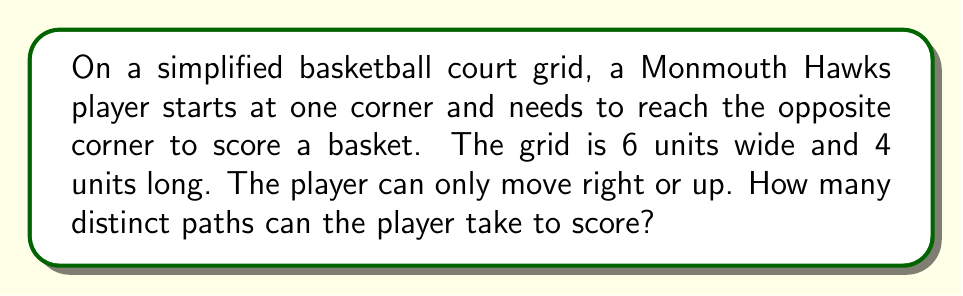Can you answer this question? Let's approach this step-by-step:

1) This is a classic combinatorics problem that can be solved using the concept of lattice paths.

2) The player needs to move 6 units right and 4 units up in total, regardless of the order.

3) Each distinct path will consist of exactly 10 moves (6 right + 4 up).

4) The question is essentially asking: in how many ways can we arrange 6 right moves and 4 up moves?

5) This is equivalent to choosing positions for either the right moves or the up moves out of the total 10 positions.

6) We can use the combination formula:

   $$\binom{10}{6} = \binom{10}{4}$$

7) This can be calculated as:

   $$\binom{10}{6} = \frac{10!}{6!(10-6)!} = \frac{10!}{6!4!}$$

8) Expanding this:

   $$\frac{10 * 9 * 8 * 7 * 6!}{6! * 4 * 3 * 2 * 1}$$

9) The 6! cancels out in the numerator and denominator:

   $$\frac{10 * 9 * 8 * 7}{4 * 3 * 2 * 1} = \frac{5040}{24} = 210$$

Therefore, there are 210 distinct paths the Monmouth Hawks player can take to score.
Answer: 210 